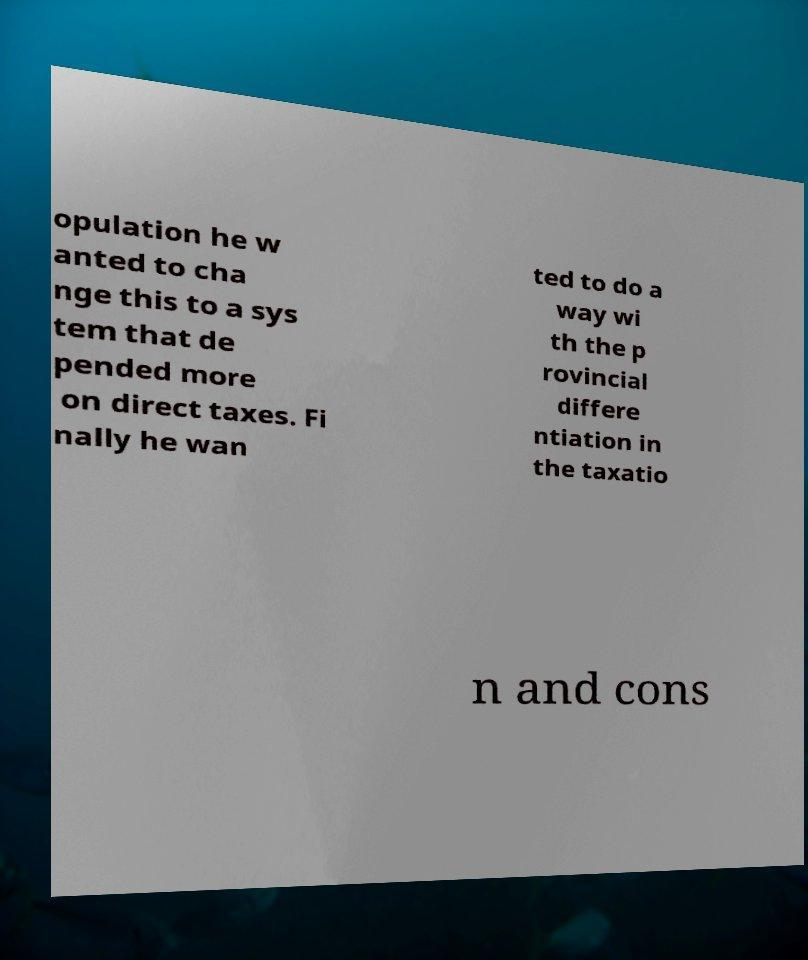For documentation purposes, I need the text within this image transcribed. Could you provide that? opulation he w anted to cha nge this to a sys tem that de pended more on direct taxes. Fi nally he wan ted to do a way wi th the p rovincial differe ntiation in the taxatio n and cons 